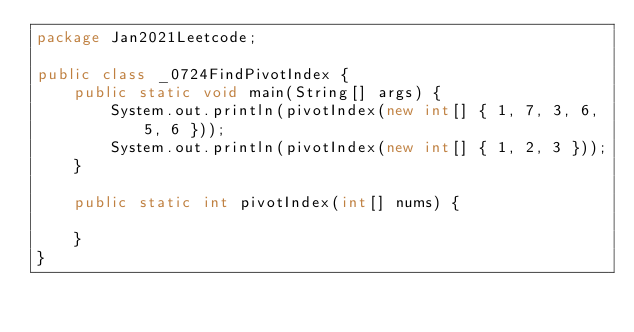<code> <loc_0><loc_0><loc_500><loc_500><_Java_>package Jan2021Leetcode;

public class _0724FindPivotIndex {
	public static void main(String[] args) {
		System.out.println(pivotIndex(new int[] { 1, 7, 3, 6, 5, 6 }));
		System.out.println(pivotIndex(new int[] { 1, 2, 3 }));
	}

	public static int pivotIndex(int[] nums) {
		
	}
}
</code> 